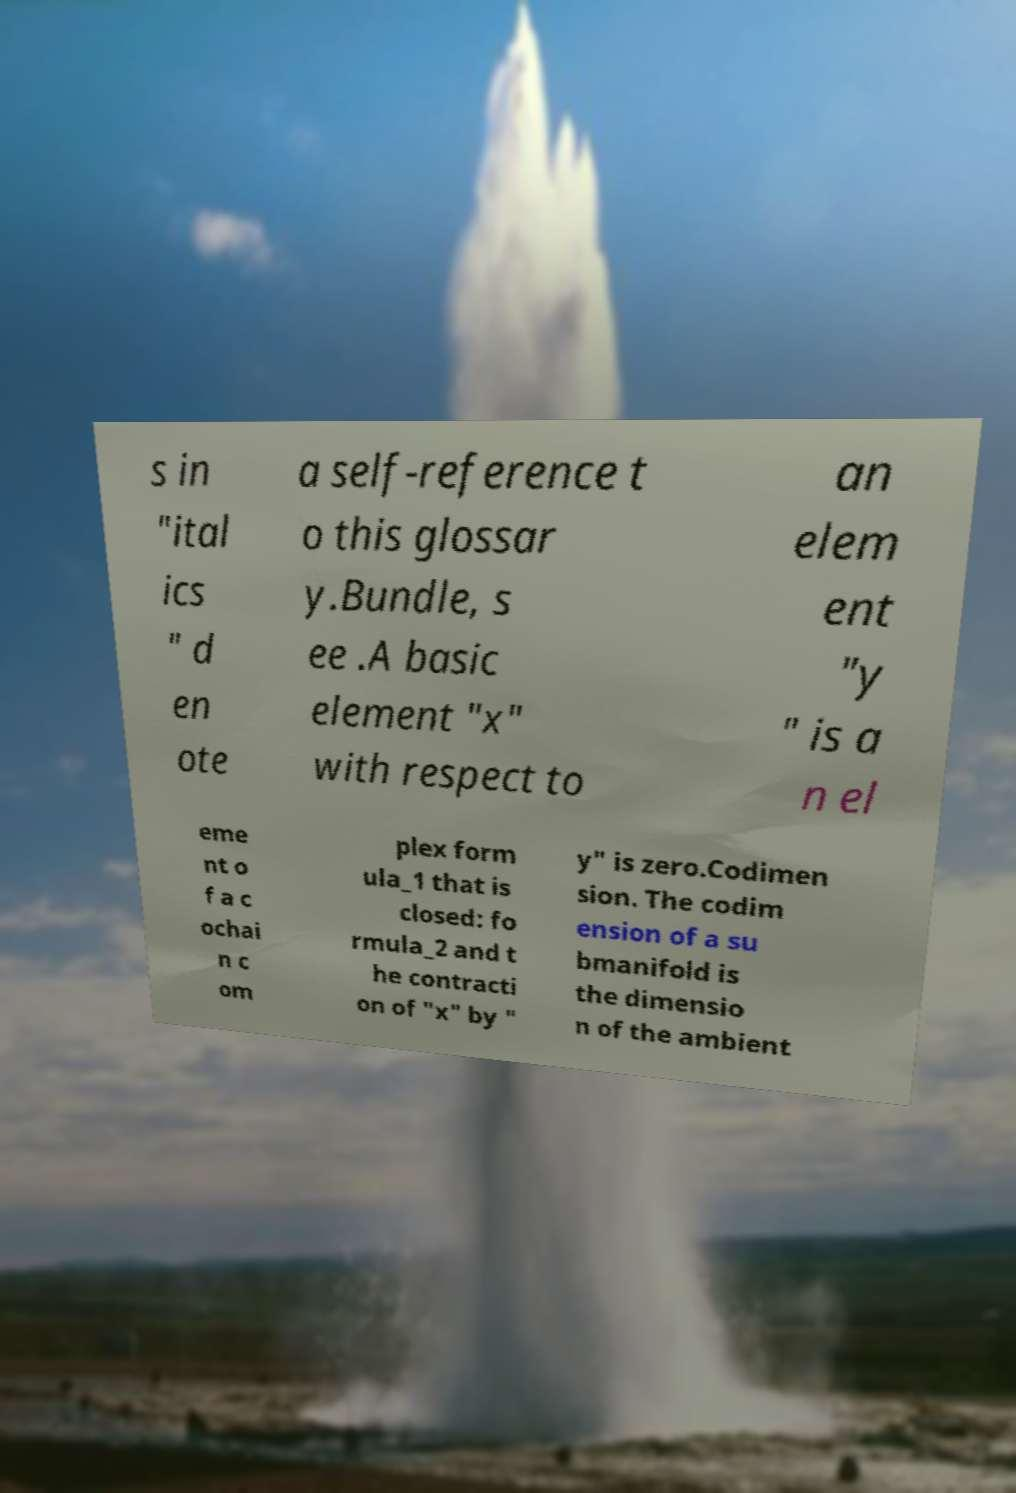Can you accurately transcribe the text from the provided image for me? s in "ital ics " d en ote a self-reference t o this glossar y.Bundle, s ee .A basic element "x" with respect to an elem ent "y " is a n el eme nt o f a c ochai n c om plex form ula_1 that is closed: fo rmula_2 and t he contracti on of "x" by " y" is zero.Codimen sion. The codim ension of a su bmanifold is the dimensio n of the ambient 